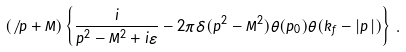<formula> <loc_0><loc_0><loc_500><loc_500>( \not \, p + M ) \left \{ \frac { i } { p ^ { 2 } - M ^ { 2 } + i \varepsilon } - 2 \pi \delta ( p ^ { 2 } - M ^ { 2 } ) \theta ( p _ { 0 } ) \theta ( k _ { f } - | \vec { p } \, | ) \right \} \, .</formula> 